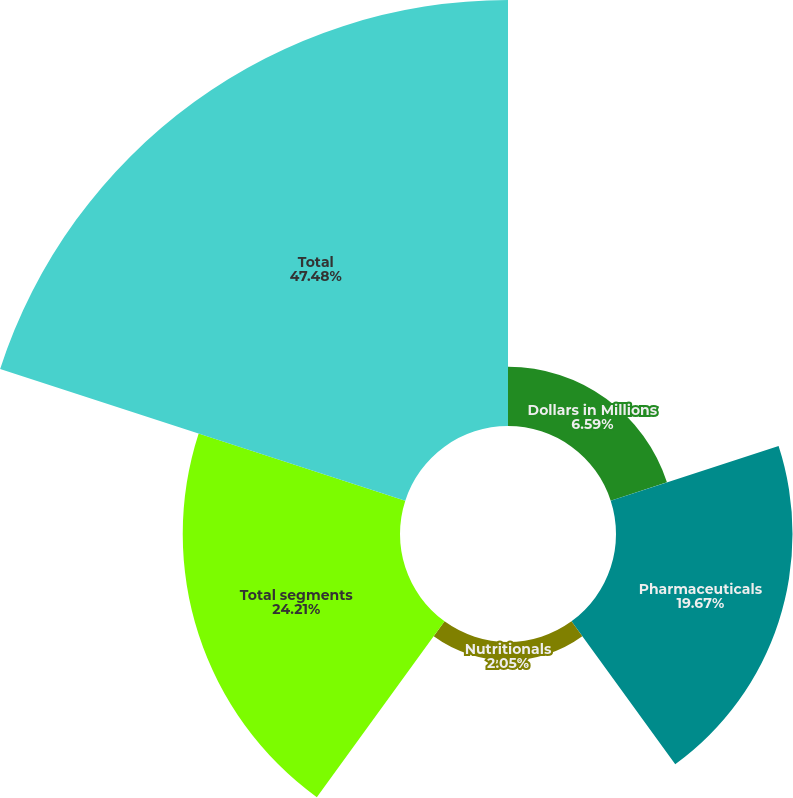<chart> <loc_0><loc_0><loc_500><loc_500><pie_chart><fcel>Dollars in Millions<fcel>Pharmaceuticals<fcel>Nutritionals<fcel>Total segments<fcel>Total<nl><fcel>6.59%<fcel>19.67%<fcel>2.05%<fcel>24.21%<fcel>47.47%<nl></chart> 